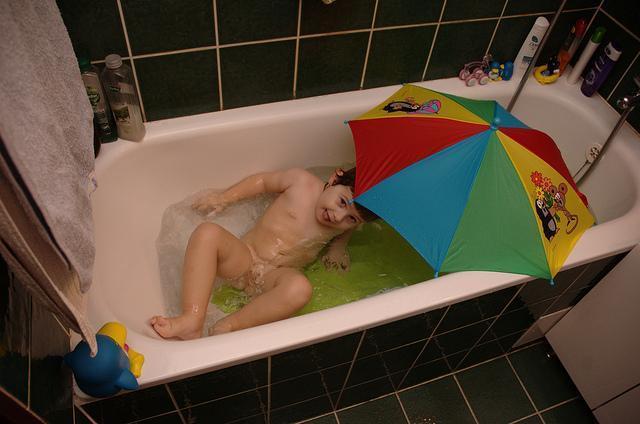Is the statement "The person is at the left side of the umbrella." accurate regarding the image?
Answer yes or no. Yes. 